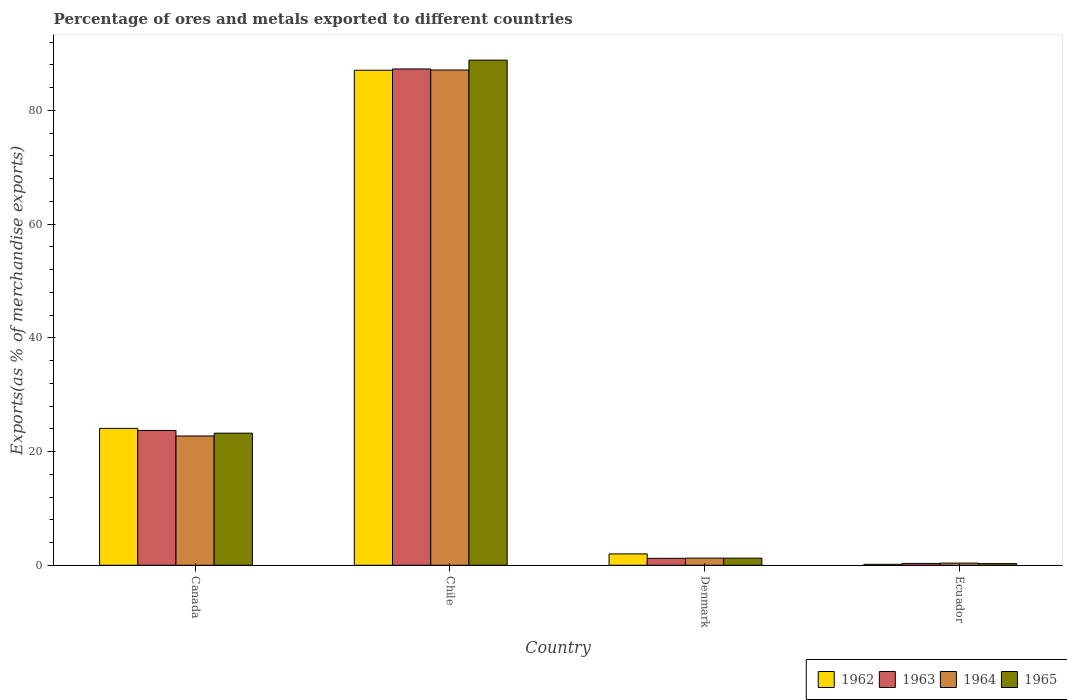Are the number of bars on each tick of the X-axis equal?
Offer a very short reply. Yes. How many bars are there on the 3rd tick from the left?
Make the answer very short. 4. How many bars are there on the 3rd tick from the right?
Offer a terse response. 4. What is the percentage of exports to different countries in 1962 in Ecuador?
Offer a very short reply. 0.17. Across all countries, what is the maximum percentage of exports to different countries in 1964?
Your answer should be very brief. 87.1. Across all countries, what is the minimum percentage of exports to different countries in 1965?
Offer a terse response. 0.29. In which country was the percentage of exports to different countries in 1963 minimum?
Your response must be concise. Ecuador. What is the total percentage of exports to different countries in 1964 in the graph?
Ensure brevity in your answer.  111.47. What is the difference between the percentage of exports to different countries in 1962 in Chile and that in Denmark?
Your response must be concise. 85.06. What is the difference between the percentage of exports to different countries in 1964 in Canada and the percentage of exports to different countries in 1965 in Chile?
Make the answer very short. -66.1. What is the average percentage of exports to different countries in 1965 per country?
Provide a succinct answer. 28.4. What is the difference between the percentage of exports to different countries of/in 1963 and percentage of exports to different countries of/in 1962 in Canada?
Provide a short and direct response. -0.37. What is the ratio of the percentage of exports to different countries in 1965 in Denmark to that in Ecuador?
Your answer should be very brief. 4.29. What is the difference between the highest and the second highest percentage of exports to different countries in 1962?
Ensure brevity in your answer.  22.07. What is the difference between the highest and the lowest percentage of exports to different countries in 1965?
Offer a terse response. 88.54. Is the sum of the percentage of exports to different countries in 1963 in Chile and Denmark greater than the maximum percentage of exports to different countries in 1964 across all countries?
Give a very brief answer. Yes. What does the 1st bar from the right in Canada represents?
Make the answer very short. 1965. Is it the case that in every country, the sum of the percentage of exports to different countries in 1965 and percentage of exports to different countries in 1963 is greater than the percentage of exports to different countries in 1964?
Make the answer very short. Yes. How many bars are there?
Ensure brevity in your answer.  16. Are the values on the major ticks of Y-axis written in scientific E-notation?
Provide a succinct answer. No. Does the graph contain any zero values?
Keep it short and to the point. No. Where does the legend appear in the graph?
Provide a short and direct response. Bottom right. What is the title of the graph?
Your answer should be compact. Percentage of ores and metals exported to different countries. What is the label or title of the Y-axis?
Offer a terse response. Exports(as % of merchandise exports). What is the Exports(as % of merchandise exports) of 1962 in Canada?
Give a very brief answer. 24.07. What is the Exports(as % of merchandise exports) in 1963 in Canada?
Provide a succinct answer. 23.71. What is the Exports(as % of merchandise exports) of 1964 in Canada?
Keep it short and to the point. 22.74. What is the Exports(as % of merchandise exports) of 1965 in Canada?
Your response must be concise. 23.23. What is the Exports(as % of merchandise exports) in 1962 in Chile?
Your answer should be compact. 87.06. What is the Exports(as % of merchandise exports) in 1963 in Chile?
Provide a short and direct response. 87.28. What is the Exports(as % of merchandise exports) in 1964 in Chile?
Provide a succinct answer. 87.1. What is the Exports(as % of merchandise exports) of 1965 in Chile?
Ensure brevity in your answer.  88.84. What is the Exports(as % of merchandise exports) of 1962 in Denmark?
Offer a very short reply. 2. What is the Exports(as % of merchandise exports) in 1963 in Denmark?
Make the answer very short. 1.22. What is the Exports(as % of merchandise exports) of 1964 in Denmark?
Provide a succinct answer. 1.25. What is the Exports(as % of merchandise exports) in 1965 in Denmark?
Keep it short and to the point. 1.25. What is the Exports(as % of merchandise exports) in 1962 in Ecuador?
Make the answer very short. 0.17. What is the Exports(as % of merchandise exports) in 1963 in Ecuador?
Offer a terse response. 0.32. What is the Exports(as % of merchandise exports) of 1964 in Ecuador?
Offer a terse response. 0.38. What is the Exports(as % of merchandise exports) of 1965 in Ecuador?
Offer a very short reply. 0.29. Across all countries, what is the maximum Exports(as % of merchandise exports) in 1962?
Offer a terse response. 87.06. Across all countries, what is the maximum Exports(as % of merchandise exports) of 1963?
Your answer should be very brief. 87.28. Across all countries, what is the maximum Exports(as % of merchandise exports) of 1964?
Offer a terse response. 87.1. Across all countries, what is the maximum Exports(as % of merchandise exports) of 1965?
Your response must be concise. 88.84. Across all countries, what is the minimum Exports(as % of merchandise exports) of 1962?
Give a very brief answer. 0.17. Across all countries, what is the minimum Exports(as % of merchandise exports) of 1963?
Your response must be concise. 0.32. Across all countries, what is the minimum Exports(as % of merchandise exports) of 1964?
Keep it short and to the point. 0.38. Across all countries, what is the minimum Exports(as % of merchandise exports) of 1965?
Ensure brevity in your answer.  0.29. What is the total Exports(as % of merchandise exports) of 1962 in the graph?
Make the answer very short. 113.29. What is the total Exports(as % of merchandise exports) in 1963 in the graph?
Provide a short and direct response. 112.53. What is the total Exports(as % of merchandise exports) of 1964 in the graph?
Ensure brevity in your answer.  111.47. What is the total Exports(as % of merchandise exports) of 1965 in the graph?
Keep it short and to the point. 113.61. What is the difference between the Exports(as % of merchandise exports) in 1962 in Canada and that in Chile?
Offer a terse response. -62.98. What is the difference between the Exports(as % of merchandise exports) of 1963 in Canada and that in Chile?
Offer a terse response. -63.58. What is the difference between the Exports(as % of merchandise exports) in 1964 in Canada and that in Chile?
Ensure brevity in your answer.  -64.36. What is the difference between the Exports(as % of merchandise exports) in 1965 in Canada and that in Chile?
Your response must be concise. -65.61. What is the difference between the Exports(as % of merchandise exports) in 1962 in Canada and that in Denmark?
Offer a very short reply. 22.07. What is the difference between the Exports(as % of merchandise exports) in 1963 in Canada and that in Denmark?
Make the answer very short. 22.49. What is the difference between the Exports(as % of merchandise exports) in 1964 in Canada and that in Denmark?
Make the answer very short. 21.48. What is the difference between the Exports(as % of merchandise exports) of 1965 in Canada and that in Denmark?
Provide a succinct answer. 21.98. What is the difference between the Exports(as % of merchandise exports) in 1962 in Canada and that in Ecuador?
Your answer should be very brief. 23.91. What is the difference between the Exports(as % of merchandise exports) in 1963 in Canada and that in Ecuador?
Make the answer very short. 23.39. What is the difference between the Exports(as % of merchandise exports) in 1964 in Canada and that in Ecuador?
Ensure brevity in your answer.  22.36. What is the difference between the Exports(as % of merchandise exports) in 1965 in Canada and that in Ecuador?
Offer a terse response. 22.94. What is the difference between the Exports(as % of merchandise exports) in 1962 in Chile and that in Denmark?
Give a very brief answer. 85.06. What is the difference between the Exports(as % of merchandise exports) in 1963 in Chile and that in Denmark?
Give a very brief answer. 86.06. What is the difference between the Exports(as % of merchandise exports) in 1964 in Chile and that in Denmark?
Ensure brevity in your answer.  85.84. What is the difference between the Exports(as % of merchandise exports) in 1965 in Chile and that in Denmark?
Keep it short and to the point. 87.58. What is the difference between the Exports(as % of merchandise exports) in 1962 in Chile and that in Ecuador?
Offer a terse response. 86.89. What is the difference between the Exports(as % of merchandise exports) of 1963 in Chile and that in Ecuador?
Offer a very short reply. 86.96. What is the difference between the Exports(as % of merchandise exports) of 1964 in Chile and that in Ecuador?
Your response must be concise. 86.72. What is the difference between the Exports(as % of merchandise exports) of 1965 in Chile and that in Ecuador?
Offer a very short reply. 88.54. What is the difference between the Exports(as % of merchandise exports) in 1962 in Denmark and that in Ecuador?
Offer a very short reply. 1.83. What is the difference between the Exports(as % of merchandise exports) of 1963 in Denmark and that in Ecuador?
Your response must be concise. 0.9. What is the difference between the Exports(as % of merchandise exports) of 1964 in Denmark and that in Ecuador?
Give a very brief answer. 0.88. What is the difference between the Exports(as % of merchandise exports) in 1965 in Denmark and that in Ecuador?
Give a very brief answer. 0.96. What is the difference between the Exports(as % of merchandise exports) in 1962 in Canada and the Exports(as % of merchandise exports) in 1963 in Chile?
Your answer should be compact. -63.21. What is the difference between the Exports(as % of merchandise exports) in 1962 in Canada and the Exports(as % of merchandise exports) in 1964 in Chile?
Your response must be concise. -63.03. What is the difference between the Exports(as % of merchandise exports) in 1962 in Canada and the Exports(as % of merchandise exports) in 1965 in Chile?
Your response must be concise. -64.76. What is the difference between the Exports(as % of merchandise exports) in 1963 in Canada and the Exports(as % of merchandise exports) in 1964 in Chile?
Your answer should be very brief. -63.39. What is the difference between the Exports(as % of merchandise exports) in 1963 in Canada and the Exports(as % of merchandise exports) in 1965 in Chile?
Your answer should be compact. -65.13. What is the difference between the Exports(as % of merchandise exports) of 1964 in Canada and the Exports(as % of merchandise exports) of 1965 in Chile?
Offer a terse response. -66.1. What is the difference between the Exports(as % of merchandise exports) in 1962 in Canada and the Exports(as % of merchandise exports) in 1963 in Denmark?
Your answer should be very brief. 22.85. What is the difference between the Exports(as % of merchandise exports) in 1962 in Canada and the Exports(as % of merchandise exports) in 1964 in Denmark?
Give a very brief answer. 22.82. What is the difference between the Exports(as % of merchandise exports) in 1962 in Canada and the Exports(as % of merchandise exports) in 1965 in Denmark?
Your answer should be compact. 22.82. What is the difference between the Exports(as % of merchandise exports) of 1963 in Canada and the Exports(as % of merchandise exports) of 1964 in Denmark?
Make the answer very short. 22.45. What is the difference between the Exports(as % of merchandise exports) of 1963 in Canada and the Exports(as % of merchandise exports) of 1965 in Denmark?
Your answer should be compact. 22.45. What is the difference between the Exports(as % of merchandise exports) of 1964 in Canada and the Exports(as % of merchandise exports) of 1965 in Denmark?
Offer a terse response. 21.49. What is the difference between the Exports(as % of merchandise exports) of 1962 in Canada and the Exports(as % of merchandise exports) of 1963 in Ecuador?
Your answer should be very brief. 23.75. What is the difference between the Exports(as % of merchandise exports) of 1962 in Canada and the Exports(as % of merchandise exports) of 1964 in Ecuador?
Provide a short and direct response. 23.7. What is the difference between the Exports(as % of merchandise exports) in 1962 in Canada and the Exports(as % of merchandise exports) in 1965 in Ecuador?
Provide a succinct answer. 23.78. What is the difference between the Exports(as % of merchandise exports) of 1963 in Canada and the Exports(as % of merchandise exports) of 1964 in Ecuador?
Make the answer very short. 23.33. What is the difference between the Exports(as % of merchandise exports) of 1963 in Canada and the Exports(as % of merchandise exports) of 1965 in Ecuador?
Provide a short and direct response. 23.41. What is the difference between the Exports(as % of merchandise exports) in 1964 in Canada and the Exports(as % of merchandise exports) in 1965 in Ecuador?
Your answer should be compact. 22.45. What is the difference between the Exports(as % of merchandise exports) in 1962 in Chile and the Exports(as % of merchandise exports) in 1963 in Denmark?
Your answer should be compact. 85.84. What is the difference between the Exports(as % of merchandise exports) of 1962 in Chile and the Exports(as % of merchandise exports) of 1964 in Denmark?
Give a very brief answer. 85.8. What is the difference between the Exports(as % of merchandise exports) of 1962 in Chile and the Exports(as % of merchandise exports) of 1965 in Denmark?
Make the answer very short. 85.8. What is the difference between the Exports(as % of merchandise exports) of 1963 in Chile and the Exports(as % of merchandise exports) of 1964 in Denmark?
Your answer should be very brief. 86.03. What is the difference between the Exports(as % of merchandise exports) in 1963 in Chile and the Exports(as % of merchandise exports) in 1965 in Denmark?
Offer a very short reply. 86.03. What is the difference between the Exports(as % of merchandise exports) of 1964 in Chile and the Exports(as % of merchandise exports) of 1965 in Denmark?
Ensure brevity in your answer.  85.85. What is the difference between the Exports(as % of merchandise exports) in 1962 in Chile and the Exports(as % of merchandise exports) in 1963 in Ecuador?
Offer a terse response. 86.74. What is the difference between the Exports(as % of merchandise exports) in 1962 in Chile and the Exports(as % of merchandise exports) in 1964 in Ecuador?
Your answer should be very brief. 86.68. What is the difference between the Exports(as % of merchandise exports) in 1962 in Chile and the Exports(as % of merchandise exports) in 1965 in Ecuador?
Ensure brevity in your answer.  86.76. What is the difference between the Exports(as % of merchandise exports) of 1963 in Chile and the Exports(as % of merchandise exports) of 1964 in Ecuador?
Give a very brief answer. 86.91. What is the difference between the Exports(as % of merchandise exports) of 1963 in Chile and the Exports(as % of merchandise exports) of 1965 in Ecuador?
Your response must be concise. 86.99. What is the difference between the Exports(as % of merchandise exports) of 1964 in Chile and the Exports(as % of merchandise exports) of 1965 in Ecuador?
Keep it short and to the point. 86.81. What is the difference between the Exports(as % of merchandise exports) in 1962 in Denmark and the Exports(as % of merchandise exports) in 1963 in Ecuador?
Offer a very short reply. 1.68. What is the difference between the Exports(as % of merchandise exports) in 1962 in Denmark and the Exports(as % of merchandise exports) in 1964 in Ecuador?
Your answer should be very brief. 1.62. What is the difference between the Exports(as % of merchandise exports) in 1962 in Denmark and the Exports(as % of merchandise exports) in 1965 in Ecuador?
Your response must be concise. 1.71. What is the difference between the Exports(as % of merchandise exports) of 1963 in Denmark and the Exports(as % of merchandise exports) of 1964 in Ecuador?
Provide a succinct answer. 0.84. What is the difference between the Exports(as % of merchandise exports) in 1963 in Denmark and the Exports(as % of merchandise exports) in 1965 in Ecuador?
Your response must be concise. 0.93. What is the difference between the Exports(as % of merchandise exports) of 1964 in Denmark and the Exports(as % of merchandise exports) of 1965 in Ecuador?
Make the answer very short. 0.96. What is the average Exports(as % of merchandise exports) of 1962 per country?
Give a very brief answer. 28.32. What is the average Exports(as % of merchandise exports) in 1963 per country?
Make the answer very short. 28.13. What is the average Exports(as % of merchandise exports) in 1964 per country?
Your answer should be compact. 27.87. What is the average Exports(as % of merchandise exports) in 1965 per country?
Offer a terse response. 28.4. What is the difference between the Exports(as % of merchandise exports) of 1962 and Exports(as % of merchandise exports) of 1963 in Canada?
Offer a very short reply. 0.37. What is the difference between the Exports(as % of merchandise exports) in 1962 and Exports(as % of merchandise exports) in 1964 in Canada?
Make the answer very short. 1.33. What is the difference between the Exports(as % of merchandise exports) of 1962 and Exports(as % of merchandise exports) of 1965 in Canada?
Your answer should be compact. 0.84. What is the difference between the Exports(as % of merchandise exports) of 1963 and Exports(as % of merchandise exports) of 1964 in Canada?
Provide a short and direct response. 0.97. What is the difference between the Exports(as % of merchandise exports) of 1963 and Exports(as % of merchandise exports) of 1965 in Canada?
Offer a very short reply. 0.48. What is the difference between the Exports(as % of merchandise exports) in 1964 and Exports(as % of merchandise exports) in 1965 in Canada?
Keep it short and to the point. -0.49. What is the difference between the Exports(as % of merchandise exports) of 1962 and Exports(as % of merchandise exports) of 1963 in Chile?
Provide a succinct answer. -0.23. What is the difference between the Exports(as % of merchandise exports) in 1962 and Exports(as % of merchandise exports) in 1964 in Chile?
Your answer should be compact. -0.04. What is the difference between the Exports(as % of merchandise exports) in 1962 and Exports(as % of merchandise exports) in 1965 in Chile?
Your response must be concise. -1.78. What is the difference between the Exports(as % of merchandise exports) in 1963 and Exports(as % of merchandise exports) in 1964 in Chile?
Provide a succinct answer. 0.18. What is the difference between the Exports(as % of merchandise exports) in 1963 and Exports(as % of merchandise exports) in 1965 in Chile?
Provide a succinct answer. -1.55. What is the difference between the Exports(as % of merchandise exports) in 1964 and Exports(as % of merchandise exports) in 1965 in Chile?
Ensure brevity in your answer.  -1.74. What is the difference between the Exports(as % of merchandise exports) of 1962 and Exports(as % of merchandise exports) of 1963 in Denmark?
Your response must be concise. 0.78. What is the difference between the Exports(as % of merchandise exports) in 1962 and Exports(as % of merchandise exports) in 1964 in Denmark?
Ensure brevity in your answer.  0.74. What is the difference between the Exports(as % of merchandise exports) of 1962 and Exports(as % of merchandise exports) of 1965 in Denmark?
Offer a terse response. 0.75. What is the difference between the Exports(as % of merchandise exports) in 1963 and Exports(as % of merchandise exports) in 1964 in Denmark?
Offer a very short reply. -0.03. What is the difference between the Exports(as % of merchandise exports) of 1963 and Exports(as % of merchandise exports) of 1965 in Denmark?
Provide a succinct answer. -0.03. What is the difference between the Exports(as % of merchandise exports) of 1964 and Exports(as % of merchandise exports) of 1965 in Denmark?
Give a very brief answer. 0. What is the difference between the Exports(as % of merchandise exports) of 1962 and Exports(as % of merchandise exports) of 1963 in Ecuador?
Provide a succinct answer. -0.15. What is the difference between the Exports(as % of merchandise exports) of 1962 and Exports(as % of merchandise exports) of 1964 in Ecuador?
Give a very brief answer. -0.21. What is the difference between the Exports(as % of merchandise exports) in 1962 and Exports(as % of merchandise exports) in 1965 in Ecuador?
Offer a terse response. -0.13. What is the difference between the Exports(as % of merchandise exports) of 1963 and Exports(as % of merchandise exports) of 1964 in Ecuador?
Keep it short and to the point. -0.06. What is the difference between the Exports(as % of merchandise exports) of 1963 and Exports(as % of merchandise exports) of 1965 in Ecuador?
Provide a short and direct response. 0.03. What is the difference between the Exports(as % of merchandise exports) in 1964 and Exports(as % of merchandise exports) in 1965 in Ecuador?
Give a very brief answer. 0.08. What is the ratio of the Exports(as % of merchandise exports) of 1962 in Canada to that in Chile?
Make the answer very short. 0.28. What is the ratio of the Exports(as % of merchandise exports) in 1963 in Canada to that in Chile?
Provide a succinct answer. 0.27. What is the ratio of the Exports(as % of merchandise exports) in 1964 in Canada to that in Chile?
Keep it short and to the point. 0.26. What is the ratio of the Exports(as % of merchandise exports) of 1965 in Canada to that in Chile?
Keep it short and to the point. 0.26. What is the ratio of the Exports(as % of merchandise exports) of 1962 in Canada to that in Denmark?
Give a very brief answer. 12.05. What is the ratio of the Exports(as % of merchandise exports) of 1963 in Canada to that in Denmark?
Provide a short and direct response. 19.44. What is the ratio of the Exports(as % of merchandise exports) of 1964 in Canada to that in Denmark?
Your response must be concise. 18.13. What is the ratio of the Exports(as % of merchandise exports) of 1965 in Canada to that in Denmark?
Your answer should be very brief. 18.56. What is the ratio of the Exports(as % of merchandise exports) of 1962 in Canada to that in Ecuador?
Make the answer very short. 145.18. What is the ratio of the Exports(as % of merchandise exports) of 1963 in Canada to that in Ecuador?
Make the answer very short. 74.26. What is the ratio of the Exports(as % of merchandise exports) in 1964 in Canada to that in Ecuador?
Ensure brevity in your answer.  60.52. What is the ratio of the Exports(as % of merchandise exports) of 1965 in Canada to that in Ecuador?
Your response must be concise. 79.61. What is the ratio of the Exports(as % of merchandise exports) in 1962 in Chile to that in Denmark?
Offer a terse response. 43.58. What is the ratio of the Exports(as % of merchandise exports) in 1963 in Chile to that in Denmark?
Your answer should be compact. 71.57. What is the ratio of the Exports(as % of merchandise exports) of 1964 in Chile to that in Denmark?
Keep it short and to the point. 69.44. What is the ratio of the Exports(as % of merchandise exports) of 1965 in Chile to that in Denmark?
Offer a very short reply. 71. What is the ratio of the Exports(as % of merchandise exports) of 1962 in Chile to that in Ecuador?
Your answer should be very brief. 525.05. What is the ratio of the Exports(as % of merchandise exports) in 1963 in Chile to that in Ecuador?
Offer a very short reply. 273.43. What is the ratio of the Exports(as % of merchandise exports) of 1964 in Chile to that in Ecuador?
Provide a succinct answer. 231.84. What is the ratio of the Exports(as % of merchandise exports) of 1965 in Chile to that in Ecuador?
Your answer should be compact. 304.49. What is the ratio of the Exports(as % of merchandise exports) of 1962 in Denmark to that in Ecuador?
Provide a succinct answer. 12.05. What is the ratio of the Exports(as % of merchandise exports) of 1963 in Denmark to that in Ecuador?
Your answer should be compact. 3.82. What is the ratio of the Exports(as % of merchandise exports) in 1964 in Denmark to that in Ecuador?
Offer a very short reply. 3.34. What is the ratio of the Exports(as % of merchandise exports) in 1965 in Denmark to that in Ecuador?
Ensure brevity in your answer.  4.29. What is the difference between the highest and the second highest Exports(as % of merchandise exports) in 1962?
Offer a very short reply. 62.98. What is the difference between the highest and the second highest Exports(as % of merchandise exports) in 1963?
Give a very brief answer. 63.58. What is the difference between the highest and the second highest Exports(as % of merchandise exports) of 1964?
Offer a very short reply. 64.36. What is the difference between the highest and the second highest Exports(as % of merchandise exports) of 1965?
Provide a short and direct response. 65.61. What is the difference between the highest and the lowest Exports(as % of merchandise exports) of 1962?
Your answer should be compact. 86.89. What is the difference between the highest and the lowest Exports(as % of merchandise exports) in 1963?
Your answer should be very brief. 86.96. What is the difference between the highest and the lowest Exports(as % of merchandise exports) of 1964?
Keep it short and to the point. 86.72. What is the difference between the highest and the lowest Exports(as % of merchandise exports) of 1965?
Ensure brevity in your answer.  88.54. 